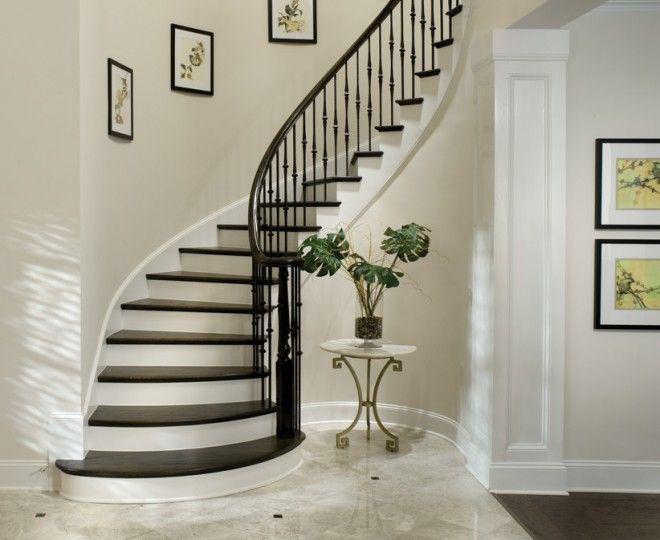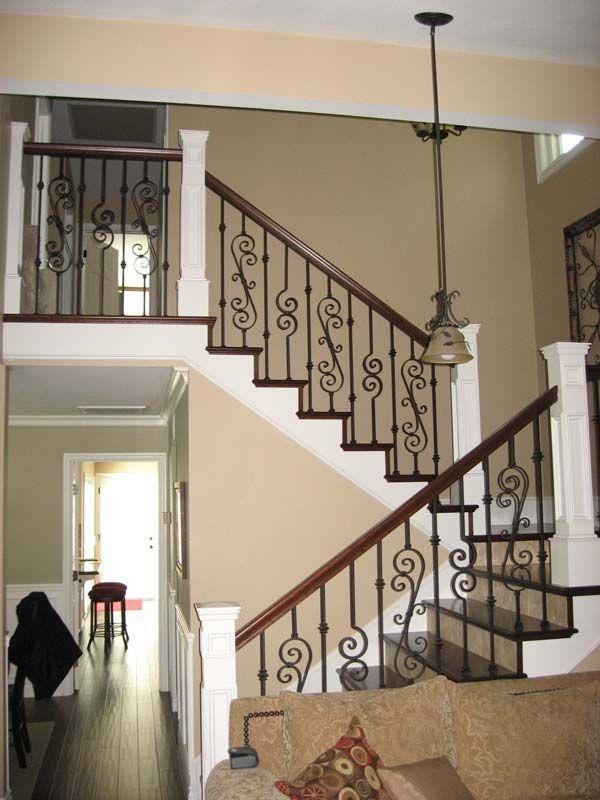The first image is the image on the left, the second image is the image on the right. Analyze the images presented: Is the assertion "One staircase's railing is white and the other's is black." valid? Answer yes or no. No. The first image is the image on the left, the second image is the image on the right. Examine the images to the left and right. Is the description "The left image shows a curving staircase with a curving rail on the right side." accurate? Answer yes or no. Yes. 